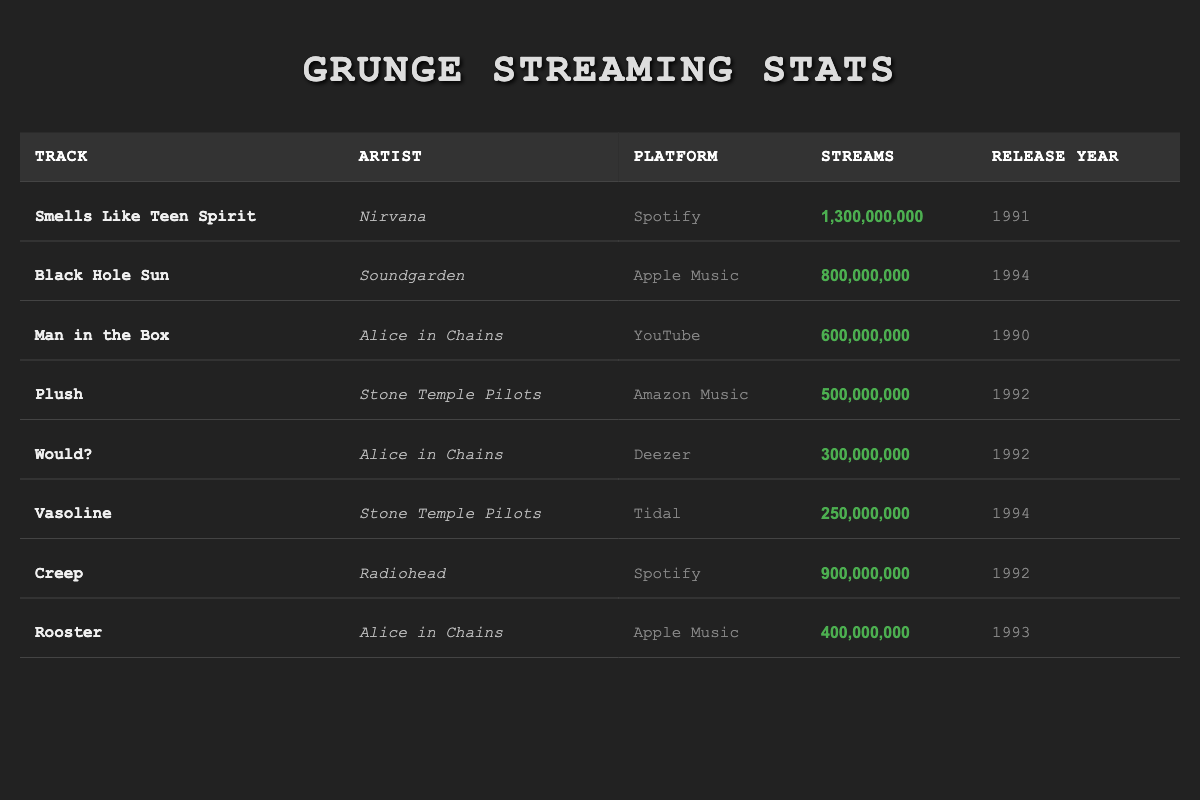What is the total number of streams for Alice in Chains tracks? Alice in Chains has three tracks listed in the table: "Man in the Box" (600,000,000 streams), "Would?" (300,000,000 streams), and "Rooster" (400,000,000 streams). To find the total, we add these values: 600,000,000 + 300,000,000 + 400,000,000 = 1,300,000,000 streams.
Answer: 1,300,000,000 Which track has the highest number of streams? The track "Smells Like Teen Spirit" by Nirvana has the highest number of streams listed in the table, with 1,300,000,000 streams. This is identified by simply looking for the maximum value in the streams column.
Answer: Smells Like Teen Spirit Are there more streams on Spotify or Apple Music for grunge tracks? The total streams for Spotify tracks are from "Smells Like Teen Spirit" (1,300,000,000) and "Creep" (900,000,000), totaling 2,200,000,000 streams. For Apple Music, the streams are from "Black Hole Sun" (800,000,000) and "Rooster" (400,000,000), totaling 1,200,000,000 streams. Comparing these totals, Spotify has more streams.
Answer: Yes, Spotify has more streams Which track was released most recently, and how many streams does it have? The most recent track listed is "Black Hole Sun" by Soundgarden, which was released in 1994. It has 800,000,000 streams. This is determined by checking the release years and identifying the maximum.
Answer: Black Hole Sun, 800,000,000 Is "Would?" by Alice in Chains more popular than "Vasoline" by Stone Temple Pilots? "Would?" has 300,000,000 streams, while "Vasoline" has 250,000,000 streams. Since 300,000,000 is greater than 250,000,000, "Would?" is more popular. This comparison is made by contrasting the streams of both tracks.
Answer: Yes, "Would?" is more popular 